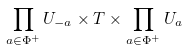Convert formula to latex. <formula><loc_0><loc_0><loc_500><loc_500>\prod _ { a \in \Phi ^ { + } } U _ { - a } \times T \times \prod _ { a \in \Phi ^ { + } } U _ { a }</formula> 